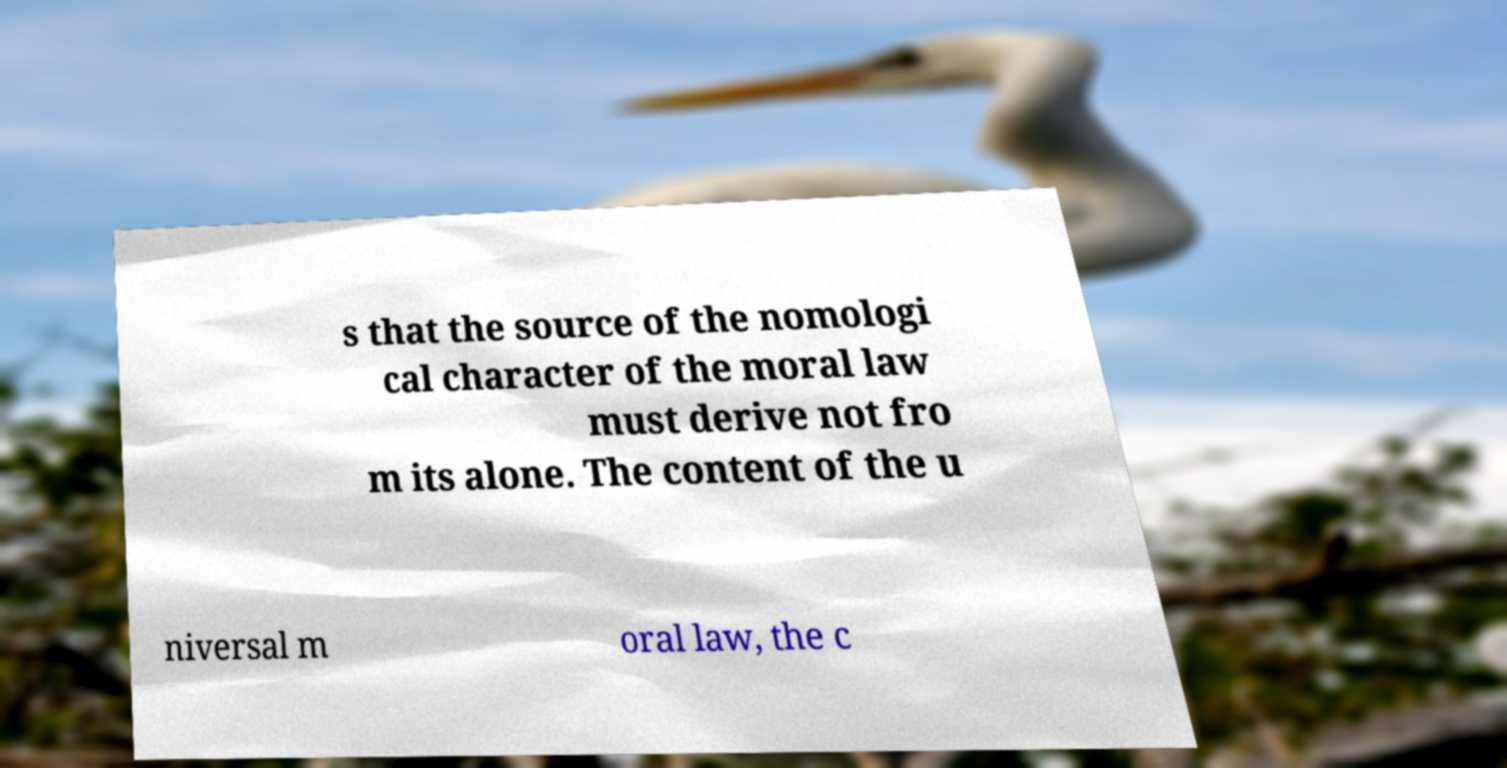Can you read and provide the text displayed in the image?This photo seems to have some interesting text. Can you extract and type it out for me? s that the source of the nomologi cal character of the moral law must derive not fro m its alone. The content of the u niversal m oral law, the c 